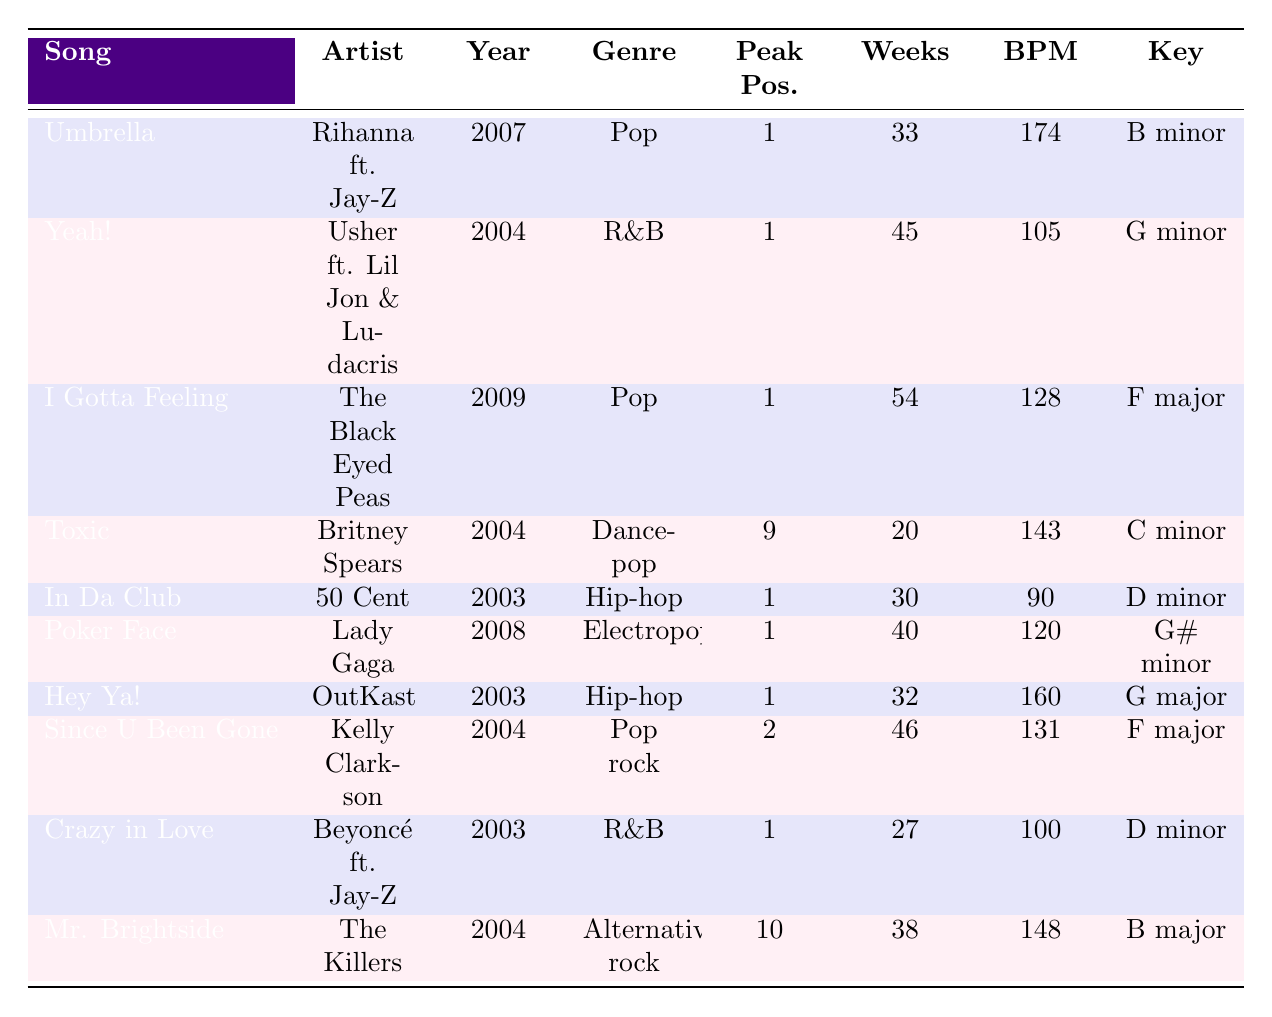What song had the highest peak position in the data? Umbrella by Rihanna ft. Jay-Z peaked at position 1, which is the highest in the data.
Answer: Umbrella How many weeks did "Yeah!" stay on the chart? Looking at the table, "Yeah!" by Usher ft. Lil Jon & Ludacris stayed on the chart for 45 weeks.
Answer: 45 weeks Which song has the highest bpm? In the table, "Umbrella" has the highest bpm at 174, while the other songs have lower bpm values.
Answer: 174 Did "Toxic" win any MTV VMA awards? The table indicates that "Toxic" by Britney Spears won 2 MTV VMA awards, which confirms it did win.
Answer: Yes What is the average number of weeks on the chart for these songs? The total number of weeks is 33 + 45 + 54 + 20 + 30 + 40 + 32 + 46 + 27 + 38 = 365. There are 10 songs, so the average is 365 / 10 = 36.5 weeks.
Answer: 36.5 weeks Which artist collaborated with Jay-Z on their song? The table shows that Rihanna collaborated with Jay-Z on "Umbrella."
Answer: Rihanna What was the sentiment of the lyrics for "I Gotta Feeling"? The table states that "I Gotta Feeling" by The Black Eyed Peas had uplifting lyrics.
Answer: Uplifting Which genre had the most songs listed in the table? By counting, Pop appears 3 times (Umbrella, I Gotta Feeling, and Since U Been Gone), making it the most frequent genre in the list.
Answer: Pop Was "Crazy in Love" released in 2004 or 2003? The table lists "Crazy in Love" by Beyoncé ft. Jay-Z as released in 2003.
Answer: 2003 How many songs in the table have a peak position greater than 5? The songs "Toxic" (9) and "Mr. Brightside" (10) have peak positions greater than 5. Counting them gives a total of 2 songs.
Answer: 2 songs What is the total number of Grammy nominations for all songs in the table? Adding the Grammy nominations gives: 3 + 2 + 1 + 1 + 3 + 2 + 4 + 2 + 3 + 0 = 22 nominations.
Answer: 22 nominations Which song has the most music video views? The table reveals that "Umbrella" has the most music video views at 785,000,000.
Answer: Umbrella What percentage of the total Spotify streams does "Poker Face" represent among the songs listed? The total Spotify streams are 1,250,000,000 + 980,000,000 + 1,100,000,000 + 850,000,000 + 1,050,000,000 + 1,300,000,000 + 920,000,000 + 680,000,000 + 1,150,000,000 + 1,450,000,000 = 10,335,000,000. "Poker Face" has 1,300,000,000 streams, so the percentage is (1,300,000,000 / 10,335,000,000) * 100 = approximately 12.6%.
Answer: 12.6% 